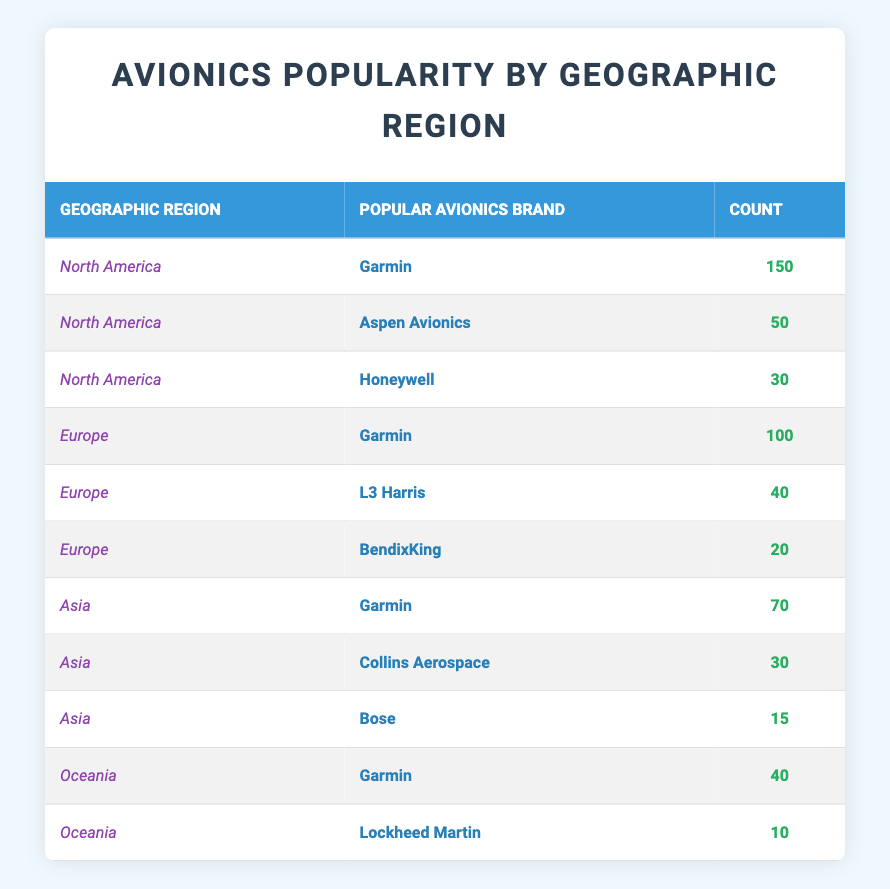What is the most popular avionics brand in North America? The table shows that Garmin has a count of 150 in North America, which is higher than the other brands (Aspen Avionics has 50 and Honeywell has 30). Therefore, Garmin is the most popular avionics brand in North America.
Answer: Garmin How many total avionics brands are listed for Europe? In Europe, there are three different avionics brands listed: Garmin, L3 Harris, and BendixKing. You can find one entry for each, making the total three brands.
Answer: 3 Which region has the least count of avionics brands overall? A review of the counts across all regions shows that Oceania has a total count of 50 (40 for Garmin and 10 for Lockheed Martin), which is less than the other regions. Hence, Oceania has the least count of avionics brands.
Answer: Oceania What is the total count of avionics brands for Asia? The total count for Asia is found by summing the counts of all listed brands: Garmin (70) + Collins Aerospace (30) + Bose (15) = 115. Therefore, the total count of avionics brands for Asia is 115.
Answer: 115 Is there any avionics brand that appears in all geographic regions? The table shows that Garmin is the only brand that appears in North America, Europe, Asia, and Oceania. This means it is the only brand common to all regions.
Answer: Yes What is the count difference of Garmin between North America and Europe? The count of Garmin in North America is 150 and in Europe it is 100. The difference is calculated as 150 - 100 = 50. Thus, upon subtraction, Garmin has a count difference of 50 between North America and Europe.
Answer: 50 Which brand has the lowest count in Oceania? In Oceania, the brands listed are Garmin with 40 and Lockheed Martin with 10. Lockheed Martin has the lowest count of 10 in Oceania.
Answer: Lockheed Martin What is the average count of avionics brands for Asia? The average count is found by summing the counts: 70 (Garmin) + 30 (Collins Aerospace) + 15 (Bose) = 115. There are 3 brands, so the average is 115 divided by 3, which gives approximately 38.33.
Answer: 38.33 